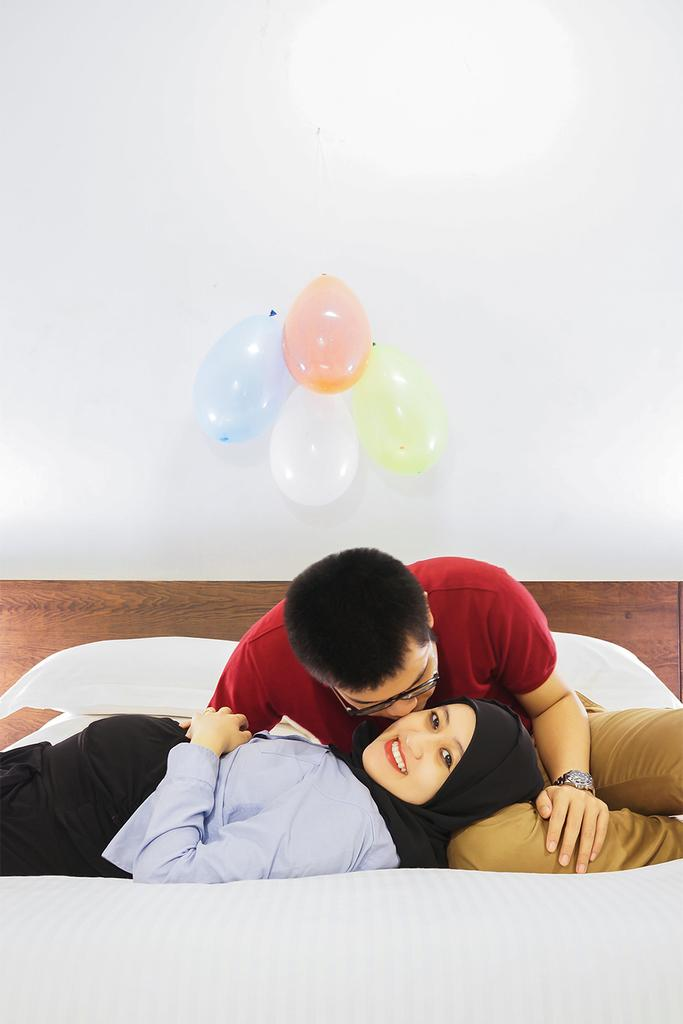What is the woman in the image doing? There is a woman sleeping in the bed. What is the man in the image doing? There is a man in the middle of the scene. What additional objects can be seen in the image? There are balloons present. How is the woman in the bed feeling? A woman is smiling. How many centimeters long is the toothbrush in the image? There is no toothbrush present in the image. What type of ground can be seen in the image? The image does not show any ground; it appears to be an indoor scene. 